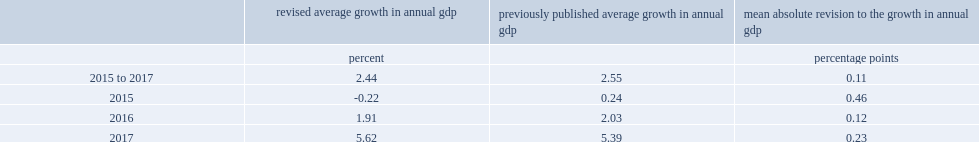How many percentage points did the annual growth rate of nominal gdp decrease after the revision in 2015? 0.46. How many percentage points did the annual growth rate of nominal gdp decrease after the revision in 2016? 0.12. 